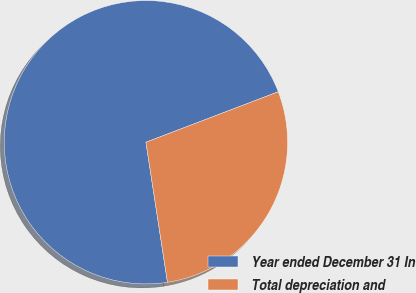Convert chart to OTSL. <chart><loc_0><loc_0><loc_500><loc_500><pie_chart><fcel>Year ended December 31 In<fcel>Total depreciation and<nl><fcel>71.63%<fcel>28.37%<nl></chart> 